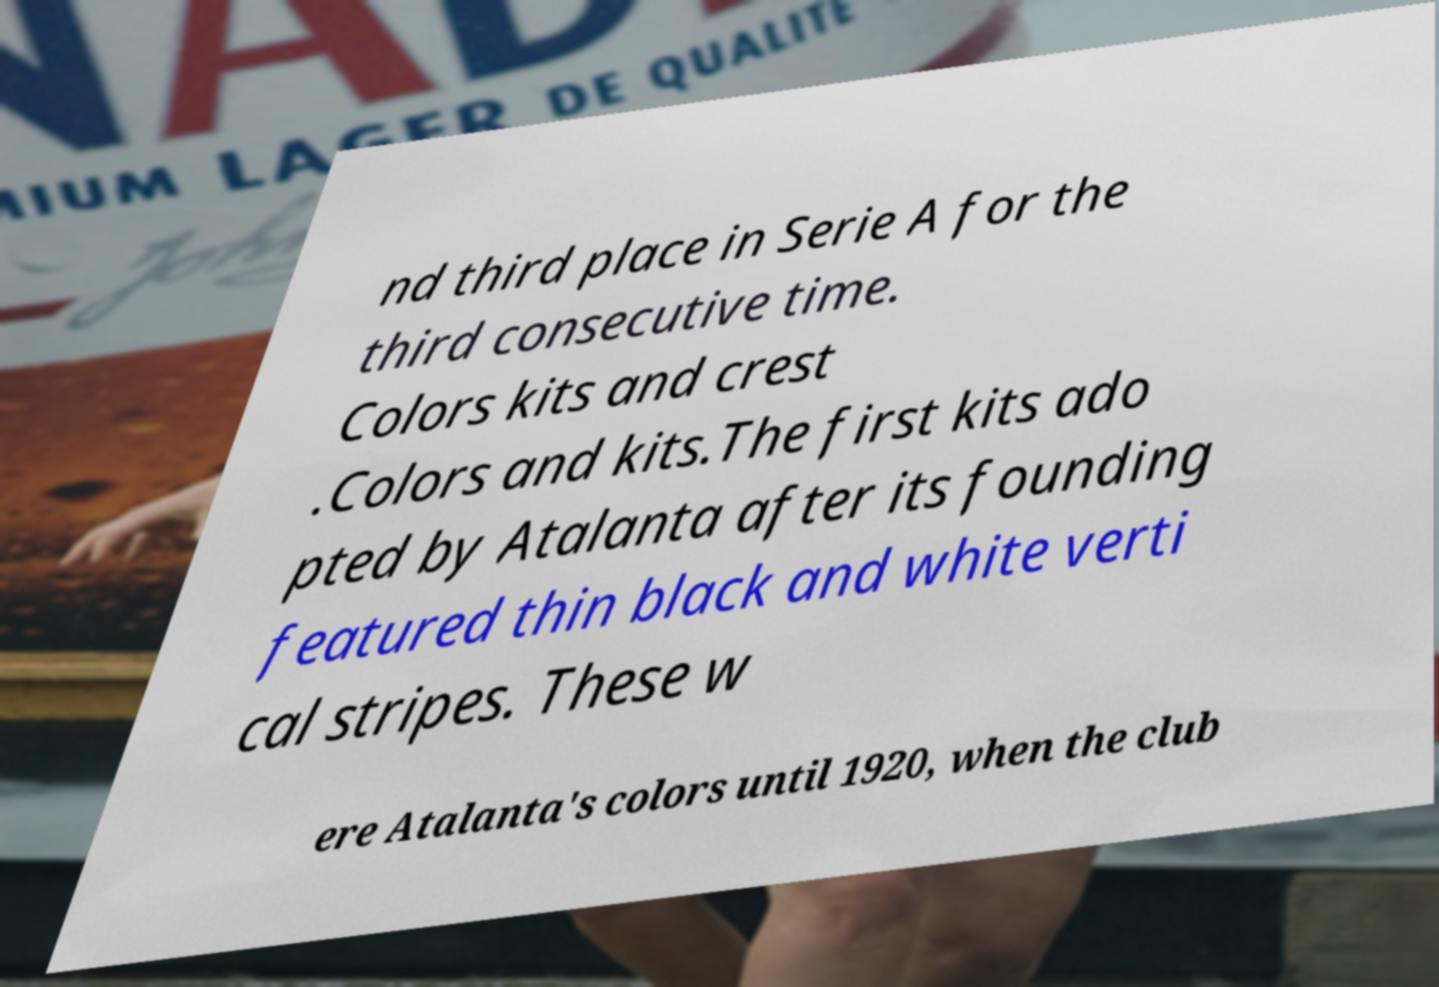There's text embedded in this image that I need extracted. Can you transcribe it verbatim? nd third place in Serie A for the third consecutive time. Colors kits and crest .Colors and kits.The first kits ado pted by Atalanta after its founding featured thin black and white verti cal stripes. These w ere Atalanta's colors until 1920, when the club 